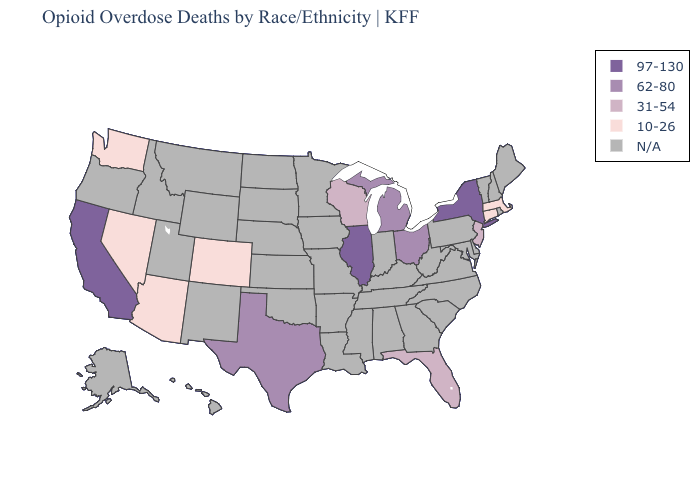Which states have the highest value in the USA?
Be succinct. California, Illinois, New York. Name the states that have a value in the range 62-80?
Give a very brief answer. Michigan, Ohio, Texas. Name the states that have a value in the range 31-54?
Concise answer only. Florida, New Jersey, Wisconsin. What is the lowest value in the Northeast?
Answer briefly. 10-26. Does the map have missing data?
Keep it brief. Yes. Among the states that border Oregon , which have the lowest value?
Short answer required. Nevada, Washington. Does the first symbol in the legend represent the smallest category?
Keep it brief. No. What is the value of Pennsylvania?
Concise answer only. N/A. Which states have the lowest value in the West?
Be succinct. Arizona, Colorado, Nevada, Washington. Name the states that have a value in the range 10-26?
Short answer required. Arizona, Colorado, Connecticut, Massachusetts, Nevada, Washington. Which states have the lowest value in the USA?
Quick response, please. Arizona, Colorado, Connecticut, Massachusetts, Nevada, Washington. What is the value of California?
Write a very short answer. 97-130. What is the value of New York?
Give a very brief answer. 97-130. Which states have the lowest value in the Northeast?
Concise answer only. Connecticut, Massachusetts. 